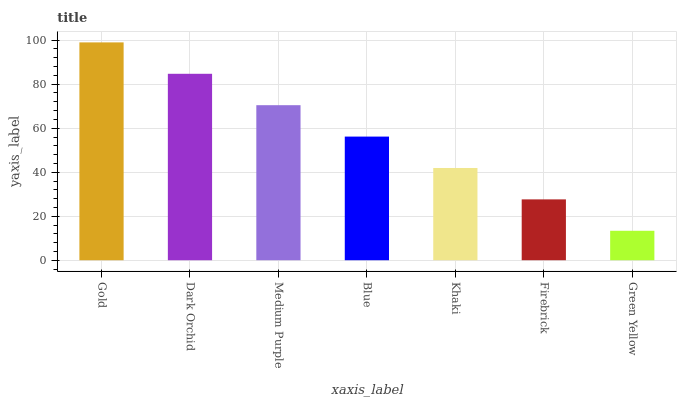Is Green Yellow the minimum?
Answer yes or no. Yes. Is Gold the maximum?
Answer yes or no. Yes. Is Dark Orchid the minimum?
Answer yes or no. No. Is Dark Orchid the maximum?
Answer yes or no. No. Is Gold greater than Dark Orchid?
Answer yes or no. Yes. Is Dark Orchid less than Gold?
Answer yes or no. Yes. Is Dark Orchid greater than Gold?
Answer yes or no. No. Is Gold less than Dark Orchid?
Answer yes or no. No. Is Blue the high median?
Answer yes or no. Yes. Is Blue the low median?
Answer yes or no. Yes. Is Medium Purple the high median?
Answer yes or no. No. Is Dark Orchid the low median?
Answer yes or no. No. 